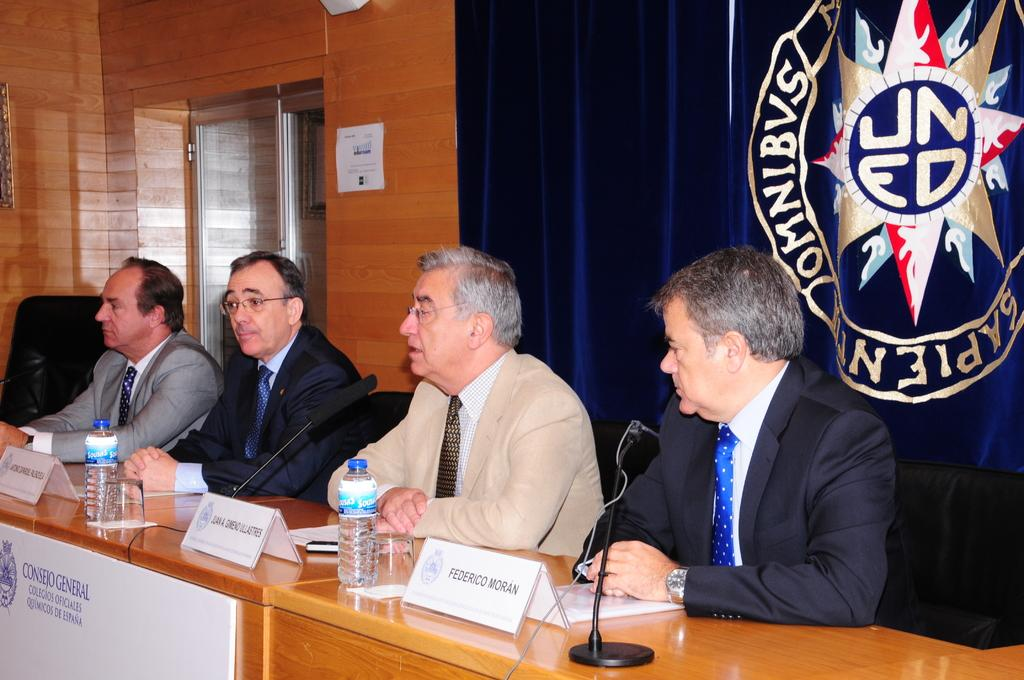<image>
Describe the image concisely. A group of men sit at a podium with a sign consejo general on the front. 